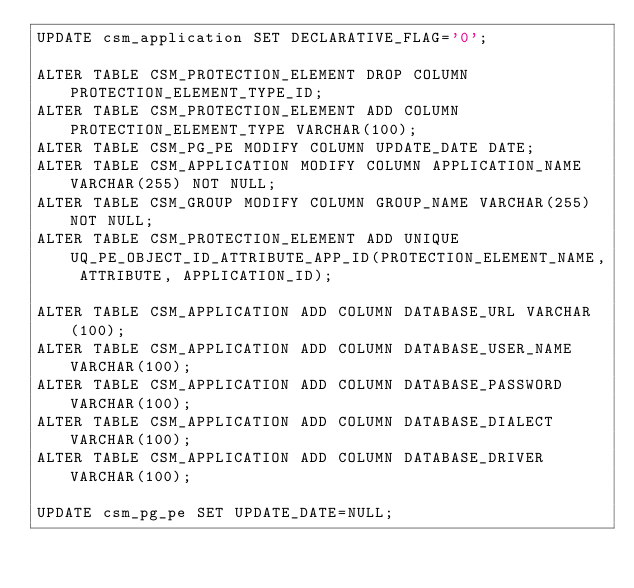<code> <loc_0><loc_0><loc_500><loc_500><_SQL_>UPDATE csm_application SET DECLARATIVE_FLAG='0';

ALTER TABLE CSM_PROTECTION_ELEMENT DROP COLUMN PROTECTION_ELEMENT_TYPE_ID;
ALTER TABLE CSM_PROTECTION_ELEMENT ADD COLUMN PROTECTION_ELEMENT_TYPE VARCHAR(100);
ALTER TABLE CSM_PG_PE MODIFY COLUMN UPDATE_DATE DATE;
ALTER TABLE CSM_APPLICATION MODIFY COLUMN APPLICATION_NAME VARCHAR(255) NOT NULL;
ALTER TABLE CSM_GROUP MODIFY COLUMN GROUP_NAME VARCHAR(255) NOT NULL;
ALTER TABLE CSM_PROTECTION_ELEMENT ADD UNIQUE UQ_PE_OBJECT_ID_ATTRIBUTE_APP_ID(PROTECTION_ELEMENT_NAME, ATTRIBUTE, APPLICATION_ID);

ALTER TABLE CSM_APPLICATION ADD COLUMN DATABASE_URL VARCHAR(100);
ALTER TABLE CSM_APPLICATION ADD COLUMN DATABASE_USER_NAME VARCHAR(100);
ALTER TABLE CSM_APPLICATION ADD COLUMN DATABASE_PASSWORD VARCHAR(100);
ALTER TABLE CSM_APPLICATION ADD COLUMN DATABASE_DIALECT VARCHAR(100);
ALTER TABLE CSM_APPLICATION ADD COLUMN DATABASE_DRIVER VARCHAR(100);

UPDATE csm_pg_pe SET UPDATE_DATE=NULL;
</code> 